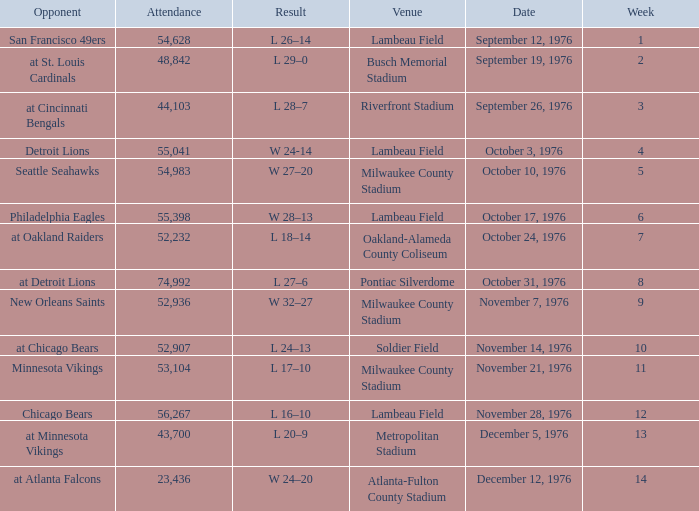What is the lowest week number where they played against the Detroit Lions? 4.0. 